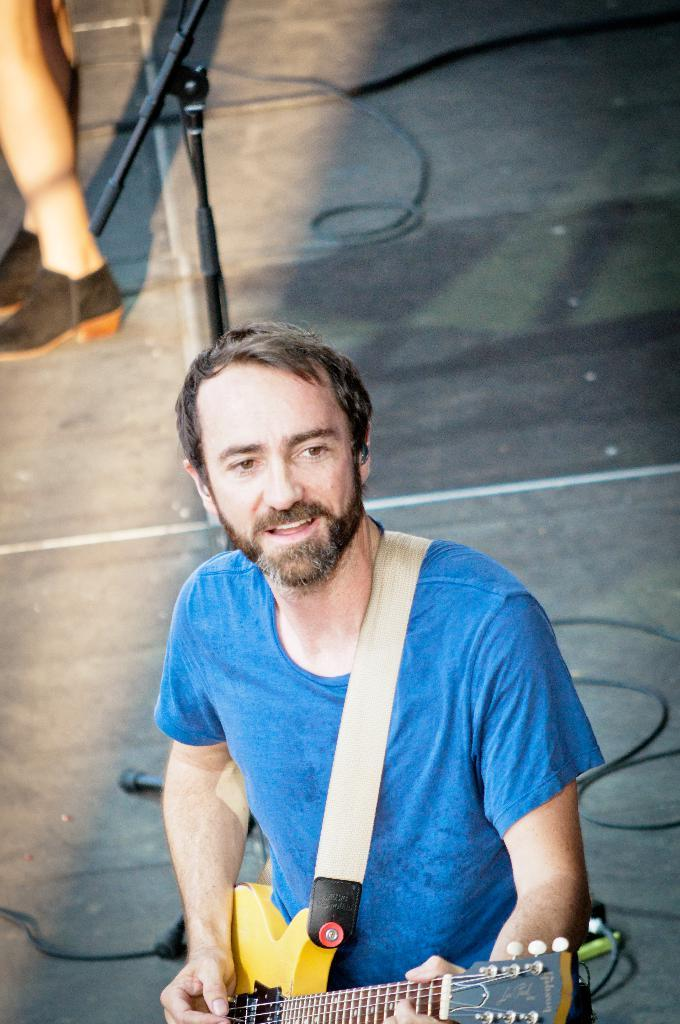What is the man in the picture doing? The man is playing the guitar. What is the man holding in the picture? The man is holding a guitar. What is the man's facial expression in the picture? The man is smiling. Can you describe the person in the background? The person in the background is standing on the road. What type of string is the man using to play the guitar in the image? The image does not provide information about the type of string being used to play the guitar. 